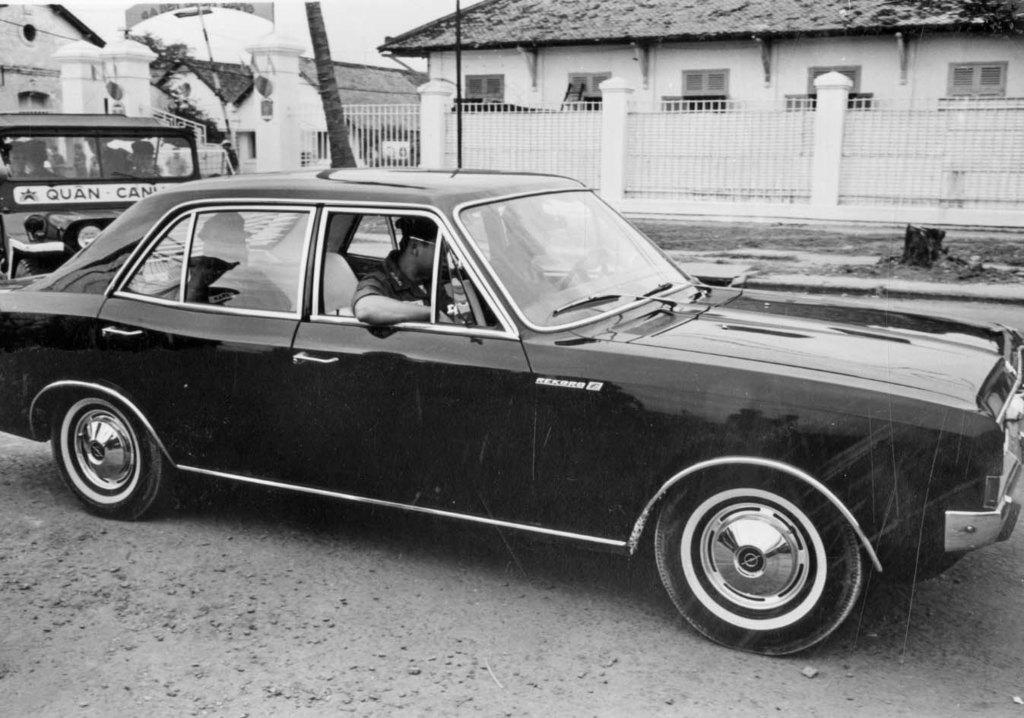What is the color scheme of the image? The image is black and white. What can be seen on the road in the image? There are two vehicles on the road. Are there any people visible in the image? Yes, there are two persons sitting inside one of the cars. What can be seen in the background of the image? There are buildings in the background of the image. Can you see a girl wearing stockings in the image? There is no girl or stockings present in the image. What type of bait is being used by the person in the car? There is no fishing or bait-related activity depicted in the image. 